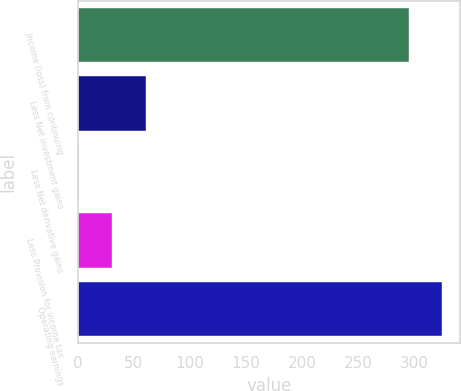Convert chart to OTSL. <chart><loc_0><loc_0><loc_500><loc_500><bar_chart><fcel>Income (loss) from continuing<fcel>Less Net investment gains<fcel>Less Net derivative gains<fcel>Less Provision for income tax<fcel>Operating earnings<nl><fcel>295<fcel>60.8<fcel>1<fcel>30.9<fcel>324.9<nl></chart> 